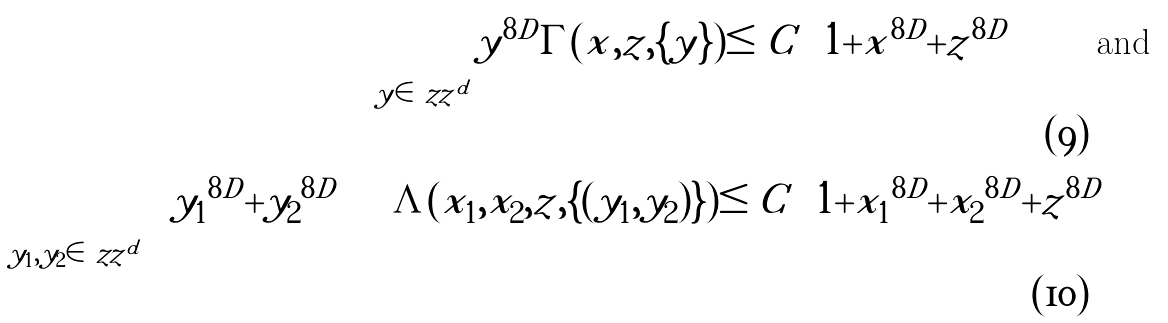<formula> <loc_0><loc_0><loc_500><loc_500>\sum _ { y \in \ z z ^ { d } } | y | ^ { 8 D } \Gamma ( x , z , \{ y \} ) \leq C \left ( 1 + | x | ^ { 8 D } + | z | ^ { 8 D } \right ) \quad \text {and} \\ \quad \sum _ { y _ { 1 } , y _ { 2 } \in \ z z ^ { d } } \left ( | y _ { 1 } | ^ { 8 D } + | y _ { 2 } | ^ { 8 D } \right ) \Lambda ( x _ { 1 } , x _ { 2 } , z , \{ ( y _ { 1 } , y _ { 2 } ) \} ) \leq C \left ( 1 + | x _ { 1 } | ^ { 8 D } + | x _ { 2 } | ^ { 8 D } + | z | ^ { 8 D } \right )</formula> 